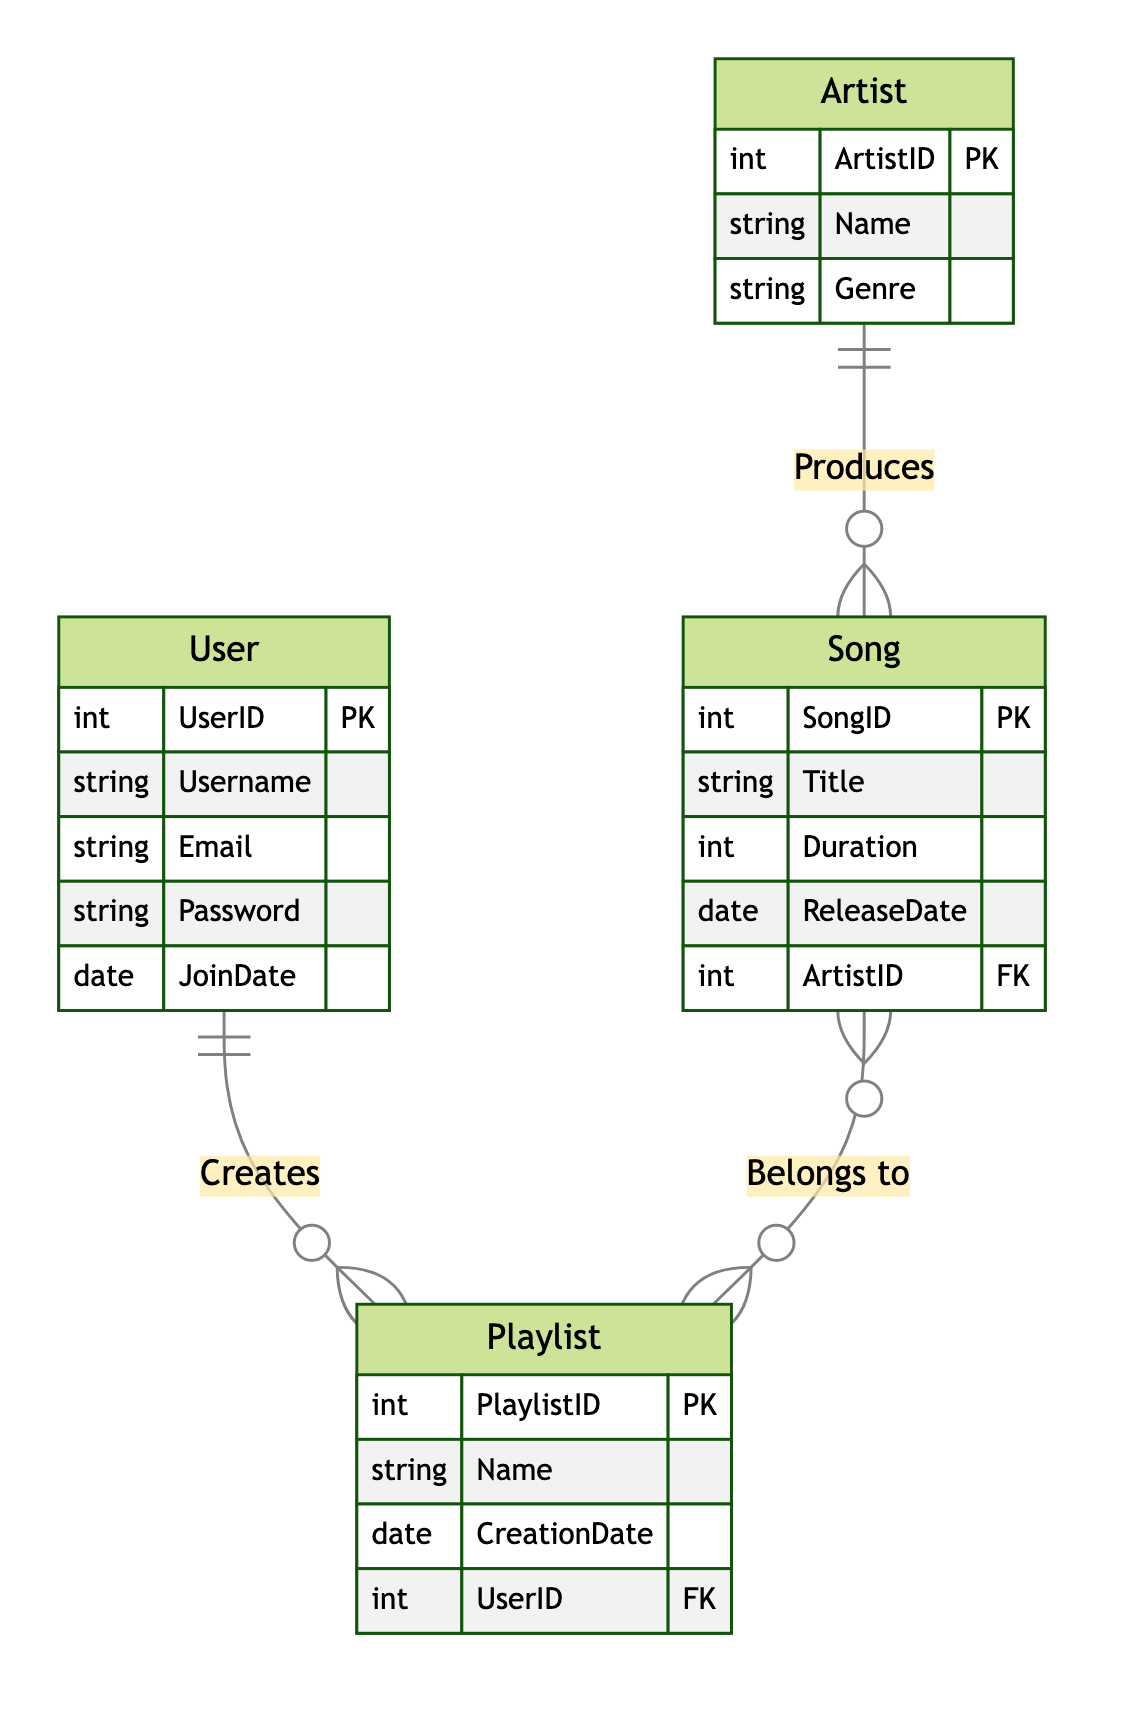What is the primary key for the User entity? The primary key for the User entity is UserID, which uniquely identifies each user in the service.
Answer: UserID How many entities are there in the diagram? The diagram contains four entities: User, Artist, Song, and Playlist. This can be counted by simply identifying each labeled box in the diagram.
Answer: Four What type of relationship exists between Artist and Song? The relationship between Artist and Song is "Produces," and it is described as a one-to-many relationship, meaning one artist can produce multiple songs.
Answer: One to Many Which attribute links a Song to its Artist? The attribute that links a Song to its Artist is ArtistID, which acts as a foreign key referencing the Artist entity.
Answer: ArtistID How many playlists can a user create? A user can create many playlists, as described in the "CreatesPlaylist" relationship, indicating a one-to-many relationship.
Answer: Many What is the primary key of the Playlist entity? The primary key of the Playlist entity is PlaylistID, which uniquely identifies each playlist.
Answer: PlaylistID How does a Song relate to Playlists? A Song can belong to many Playlists, and this relationship is many-to-many, meaning each playlist can include multiple songs as well.
Answer: Many to Many How many attributes does the Artist entity have? The Artist entity has three attributes: ArtistID, Name, and Genre. This can be counted by looking at the listed attributes in the diagram.
Answer: Three What relationship indicates a user can create playlists? The relationship that indicates a user can create playlists is called "Creates," and it is a one-to-many relationship between User and Playlist.
Answer: Creates 